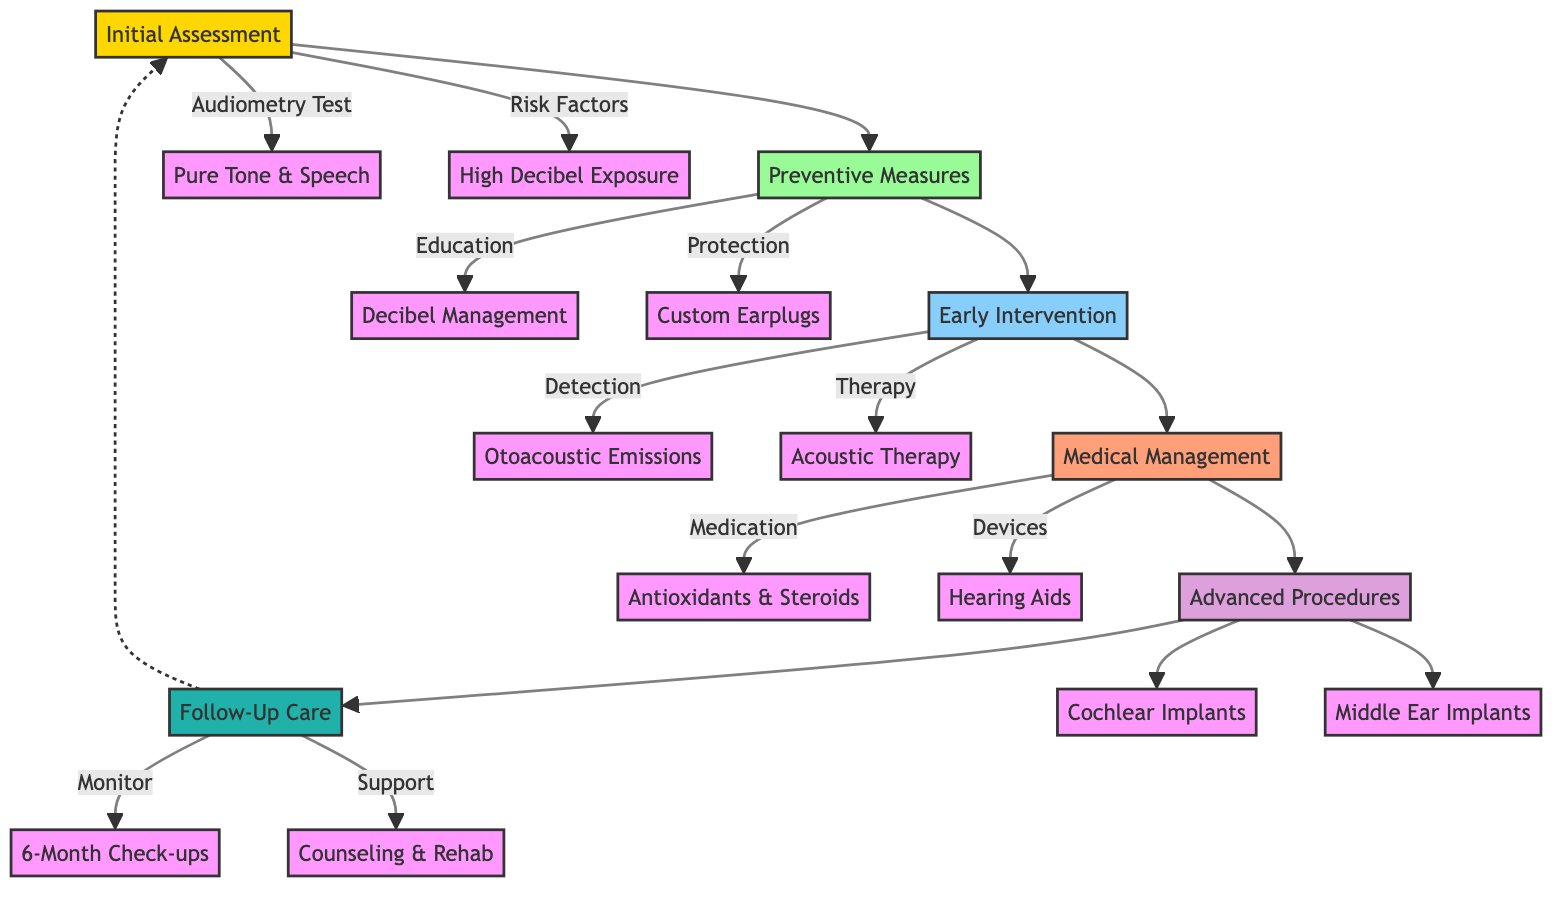What is the first step in the treatment pathway? The first step in the treatment pathway is "Initial Assessment." This is indicated at the top of the diagram as the starting point for the flow of the process.
Answer: Initial Assessment How many main sections are there in the treatment pathway? There are six main sections in the treatment pathway: Initial Assessment, Preventive Measures, Early Intervention, Medical Management, Advanced Procedures, and Follow-Up Care. This can be counted directly from the diagram layout.
Answer: Six What type of counseling is included in Follow-Up Care? The Follow-Up Care includes "Counseling Sessions." This is explicitly mentioned as part of the care and support offered to the patient after initial treatments.
Answer: Counseling Sessions What therapy falls under Early Intervention? The therapy categorized under Early Intervention is "Acoustic Therapy." This is connected directly to the early intervention branch in the diagram.
Answer: Acoustic Therapy Which devices are listed under Medical Management? The devices listed under Medical Management are "Hearing Aids." They are specified in the section detailing the available devices for mild to moderate hearing loss.
Answer: Hearing Aids How often should Periodic Hearing Checks occur? Periodic Hearing Checks should occur "every 6 months." This frequency is stated directly in the Preventive Measures section of the pathway.
Answer: Every 6 months What is assessed in the Otoacoustic Emissions Test? The Otoacoustic Emissions Test is used to measure "cochlear health." This is indicated in the Early Intervention section of the diagram.
Answer: Cochlear health What type of medication is used for acute noise exposure incidents? The medication used for acute noise exposure incidents is "Steroidal Medication." This is specifically categorized under the Medical Management section.
Answer: Steroidal Medication Which advanced procedure assesses the suitability for severe hearing loss? The advanced procedure that evaluates suitability for severe hearing loss is "Cochlear Implants Evaluation." This is highlighted in the Advanced Procedures section of the pathway.
Answer: Cochlear Implants Evaluation 